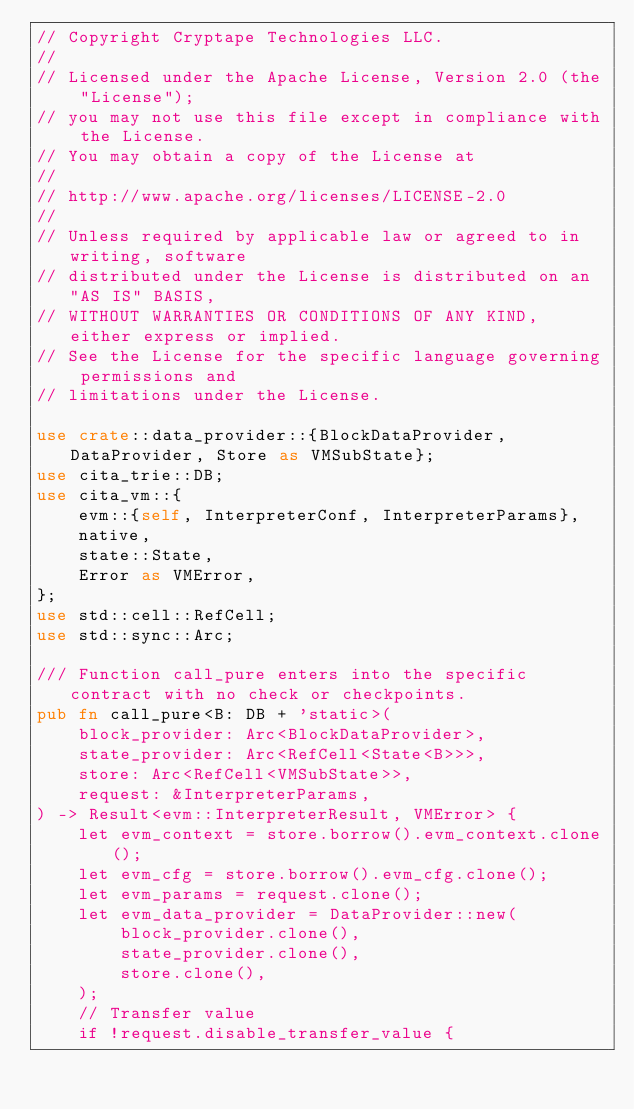Convert code to text. <code><loc_0><loc_0><loc_500><loc_500><_Rust_>// Copyright Cryptape Technologies LLC.
//
// Licensed under the Apache License, Version 2.0 (the "License");
// you may not use this file except in compliance with the License.
// You may obtain a copy of the License at
//
// http://www.apache.org/licenses/LICENSE-2.0
//
// Unless required by applicable law or agreed to in writing, software
// distributed under the License is distributed on an "AS IS" BASIS,
// WITHOUT WARRANTIES OR CONDITIONS OF ANY KIND, either express or implied.
// See the License for the specific language governing permissions and
// limitations under the License.

use crate::data_provider::{BlockDataProvider, DataProvider, Store as VMSubState};
use cita_trie::DB;
use cita_vm::{
    evm::{self, InterpreterConf, InterpreterParams},
    native,
    state::State,
    Error as VMError,
};
use std::cell::RefCell;
use std::sync::Arc;

/// Function call_pure enters into the specific contract with no check or checkpoints.
pub fn call_pure<B: DB + 'static>(
    block_provider: Arc<BlockDataProvider>,
    state_provider: Arc<RefCell<State<B>>>,
    store: Arc<RefCell<VMSubState>>,
    request: &InterpreterParams,
) -> Result<evm::InterpreterResult, VMError> {
    let evm_context = store.borrow().evm_context.clone();
    let evm_cfg = store.borrow().evm_cfg.clone();
    let evm_params = request.clone();
    let evm_data_provider = DataProvider::new(
        block_provider.clone(),
        state_provider.clone(),
        store.clone(),
    );
    // Transfer value
    if !request.disable_transfer_value {</code> 